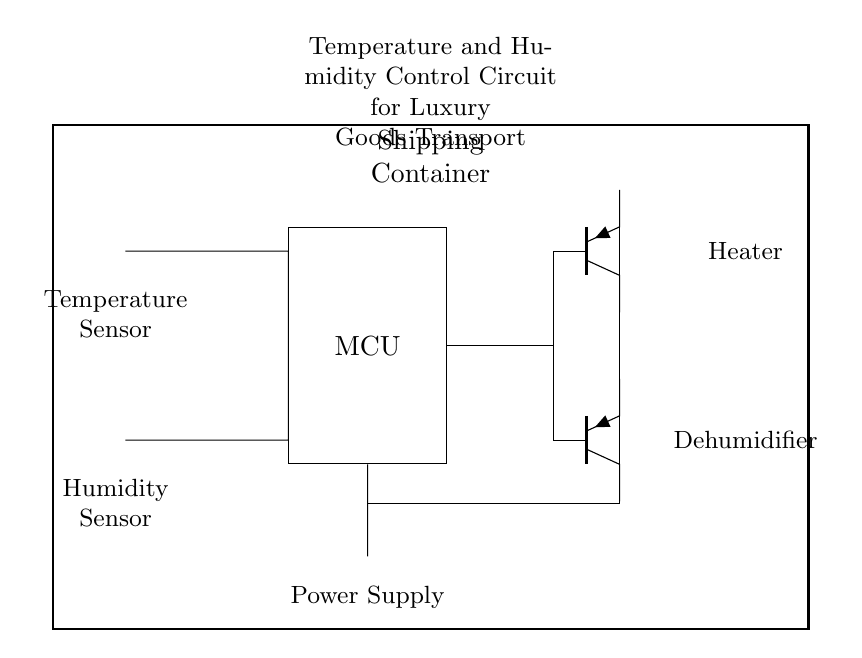What type of sensors are used in this circuit? The circuit includes a temperature sensor and a humidity sensor, which are both depicted as thermistors.
Answer: Temperature and humidity sensors What is the function of the microcontroller in this circuit? The microcontroller receives input from the sensors and controls the heater and dehumidifier based on that input.
Answer: Control unit What is the power supply type indicated in the circuit? A battery is depicted in the circuit as the power supply, which provides the necessary voltage for operation.
Answer: Battery How many actuators are controlled by the microcontroller? The microcontroller controls two actuators: a heater and a dehumidifier, both connected to it.
Answer: Two What do the PNP symbols represent in this circuit? The PNP symbols represent the heater and dehumidifier, indicating they are active when the microcontroller provides a high signal.
Answer: Active devices What is the main purpose of this control circuit? The main purpose of the circuit is to maintain optimal temperature and humidity levels for transporting luxury goods.
Answer: Environmental control What kind of connections are represented between the components? The connections include both input from sensors to the microcontroller and outputs to the actuators, indicating a feedback control loop.
Answer: Feedback control 